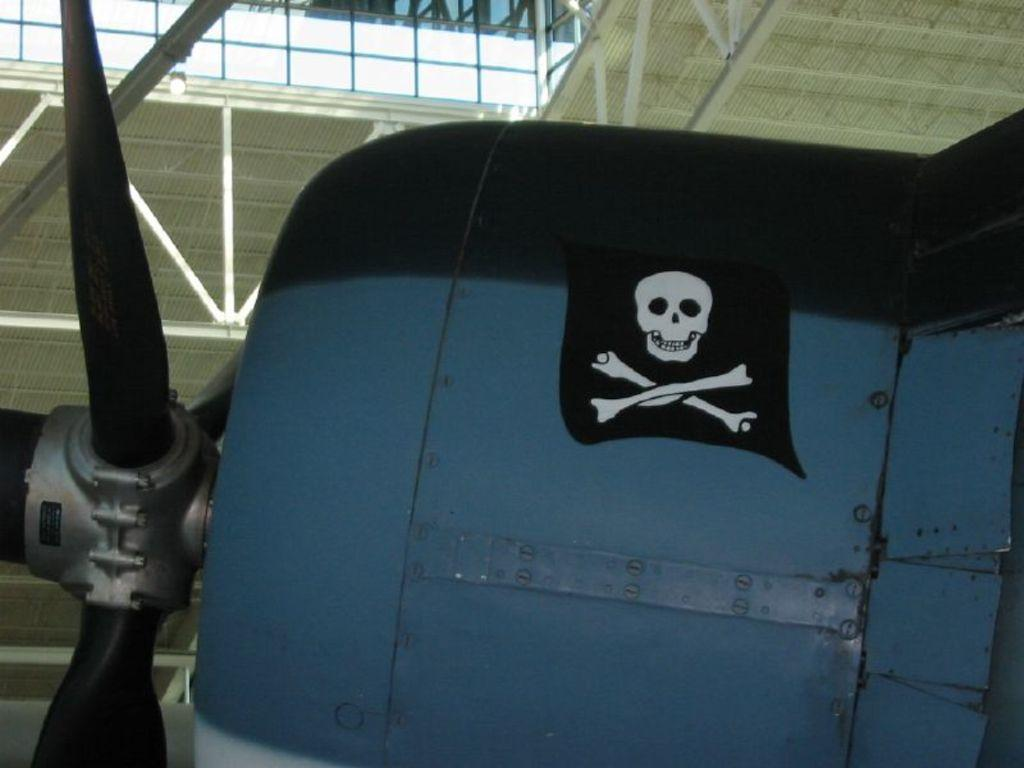What is the main subject of the image? The main subject of the image is a picture. What is depicted in the picture? The picture contains a skull. How is the skull related to the object it is attached to? The skull is attached to an object. Where is the picture located? The picture is inside a building. What type of polish is being applied to the skull in the image? There is no indication in the image that any polish is being applied to the skull. How many stomachs can be seen in the image? There are no stomachs present in the image. 